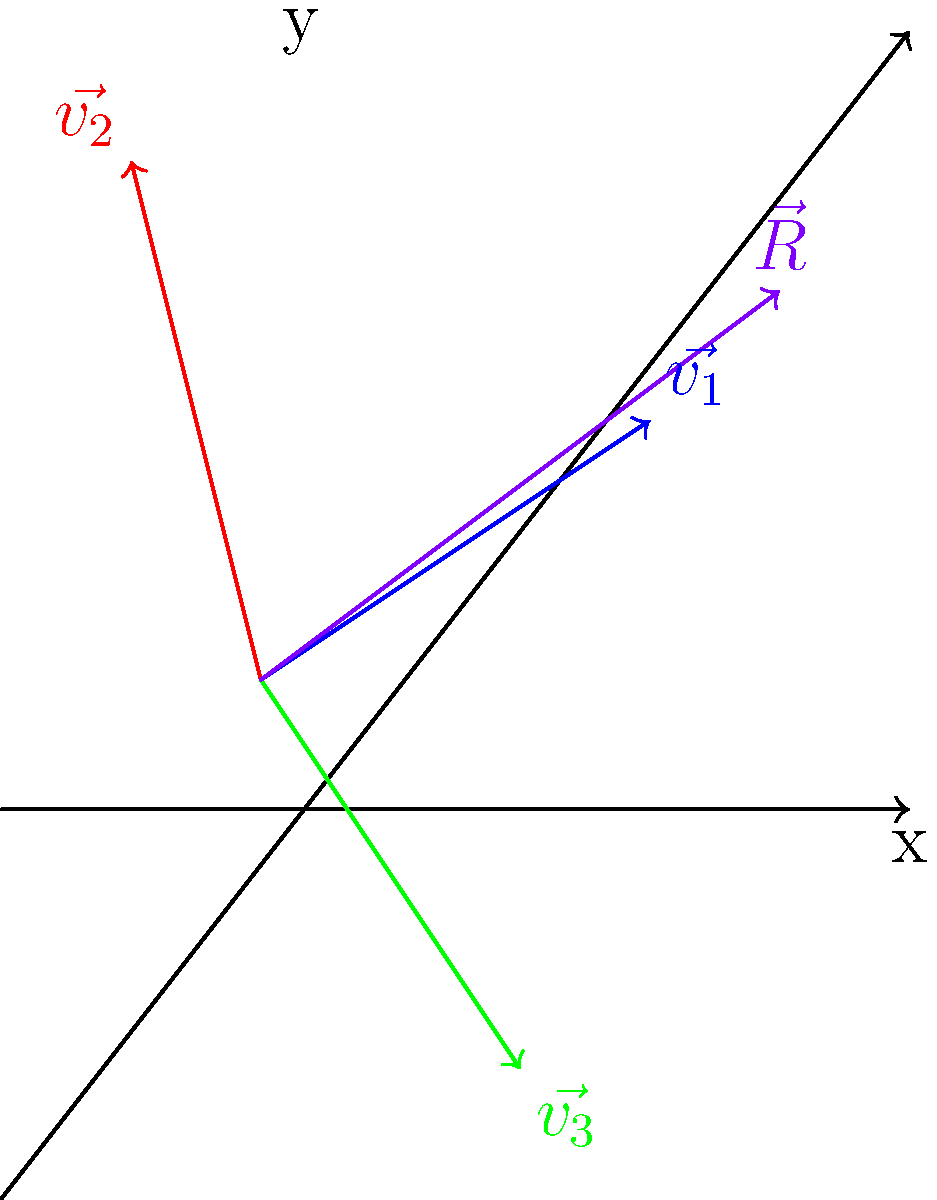Three seismic waves are interfering at a point, represented by vectors $\vec{v_1} = (3,2)$, $\vec{v_2} = (-1,4)$, and $\vec{v_3} = (2,-3)$ in a 2D coordinate system. Calculate the magnitude of the resultant vector $\vec{R}$. To find the magnitude of the resultant vector, we'll follow these steps:

1) First, we need to find the components of the resultant vector $\vec{R}$. The resultant vector is the sum of all individual vectors:

   $\vec{R} = \vec{v_1} + \vec{v_2} + \vec{v_3}$

2) Let's add the x-components:
   $R_x = 3 + (-1) + 2 = 4$

3) Now, let's add the y-components:
   $R_y = 2 + 4 + (-3) = 3$

4) So, the resultant vector $\vec{R}$ is $(4,3)$.

5) To find the magnitude of $\vec{R}$, we use the Pythagorean theorem:

   $|\vec{R}| = \sqrt{R_x^2 + R_y^2}$

6) Substituting our values:

   $|\vec{R}| = \sqrt{4^2 + 3^2} = \sqrt{16 + 9} = \sqrt{25} = 5$

Therefore, the magnitude of the resultant vector $\vec{R}$ is 5 units.
Answer: 5 units 